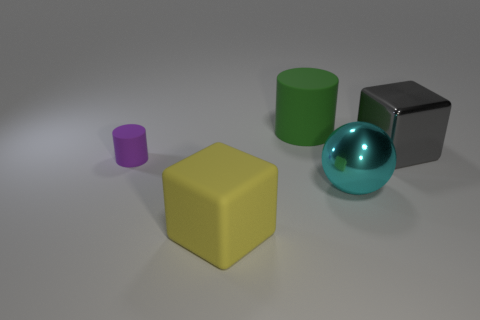What number of purple objects are either tiny matte objects or large matte cylinders?
Your answer should be compact. 1. Are there fewer purple rubber cylinders behind the green object than large green matte spheres?
Offer a very short reply. No. There is a large shiny thing that is in front of the purple rubber cylinder; what number of metal things are behind it?
Provide a short and direct response. 1. What number of other objects are there of the same size as the purple cylinder?
Offer a very short reply. 0. How many things are either large yellow cubes or large yellow matte objects in front of the gray cube?
Provide a succinct answer. 1. Is the number of large gray metal blocks less than the number of large brown metallic cubes?
Make the answer very short. No. The block on the left side of the block that is to the right of the yellow block is what color?
Ensure brevity in your answer.  Yellow. What is the material of the big yellow thing that is the same shape as the large gray object?
Offer a terse response. Rubber. What number of matte things are small red balls or big green cylinders?
Give a very brief answer. 1. Are the cylinder in front of the green object and the large block in front of the big gray metal thing made of the same material?
Keep it short and to the point. Yes. 